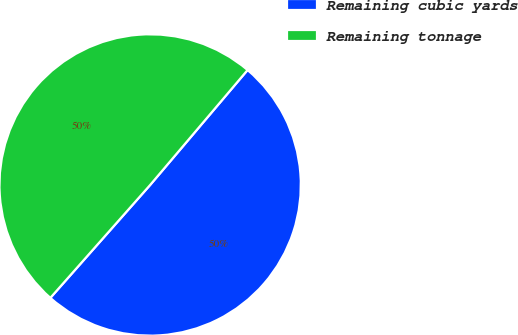Convert chart. <chart><loc_0><loc_0><loc_500><loc_500><pie_chart><fcel>Remaining cubic yards<fcel>Remaining tonnage<nl><fcel>50.33%<fcel>49.67%<nl></chart> 